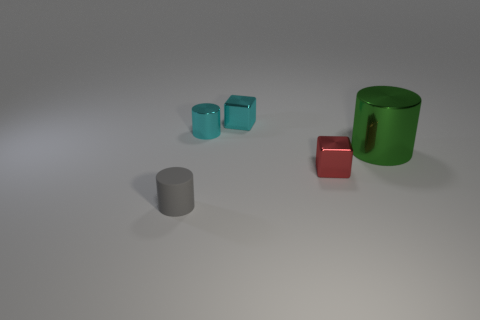Subtract all small gray rubber cylinders. How many cylinders are left? 2 Subtract all cyan cylinders. How many cylinders are left? 2 Subtract 2 cubes. How many cubes are left? 0 Subtract all cyan blocks. How many brown cylinders are left? 0 Add 3 purple cubes. How many objects exist? 8 Subtract all blocks. How many objects are left? 3 Add 5 cubes. How many cubes exist? 7 Subtract 0 cyan balls. How many objects are left? 5 Subtract all yellow cylinders. Subtract all purple balls. How many cylinders are left? 3 Subtract all small purple rubber blocks. Subtract all tiny cyan metallic cylinders. How many objects are left? 4 